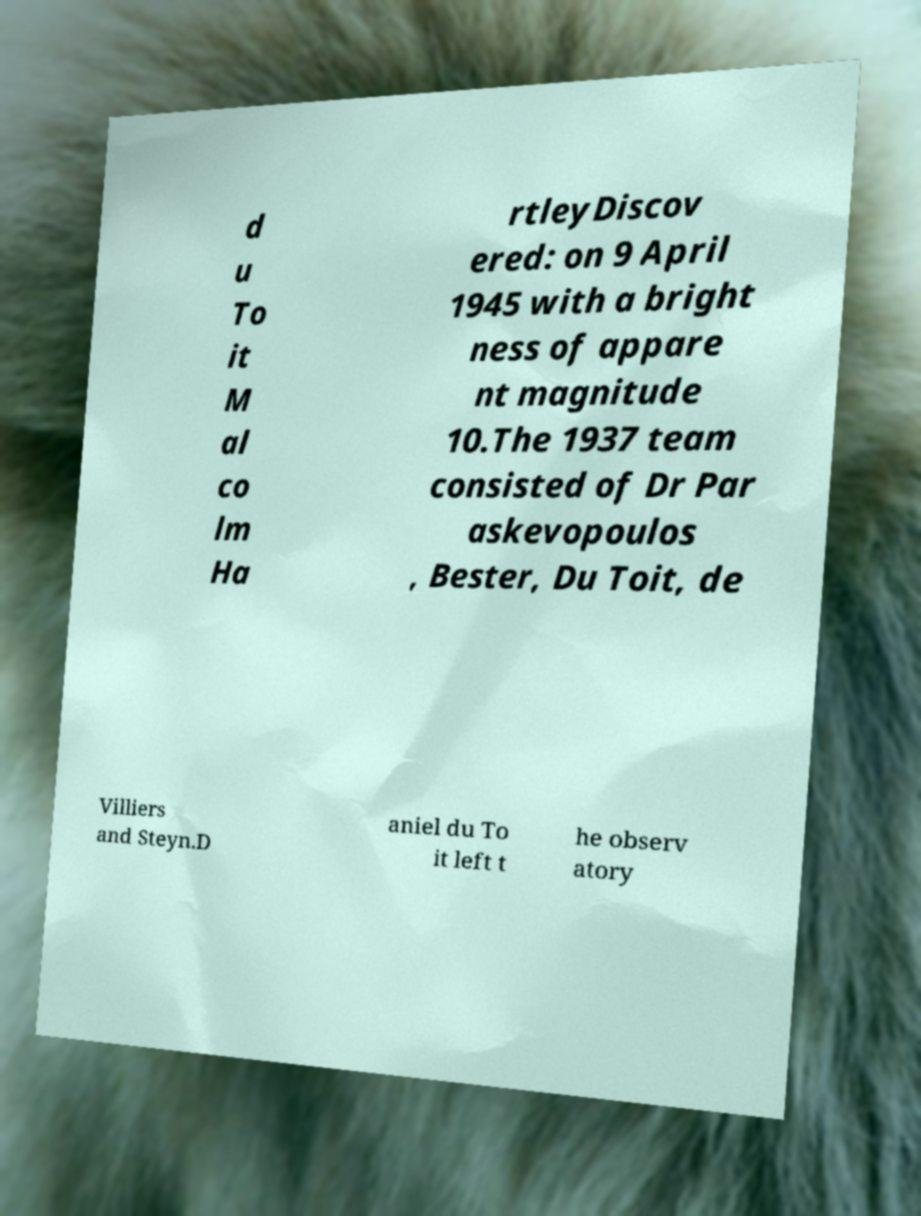Can you read and provide the text displayed in the image?This photo seems to have some interesting text. Can you extract and type it out for me? d u To it M al co lm Ha rtleyDiscov ered: on 9 April 1945 with a bright ness of appare nt magnitude 10.The 1937 team consisted of Dr Par askevopoulos , Bester, Du Toit, de Villiers and Steyn.D aniel du To it left t he observ atory 